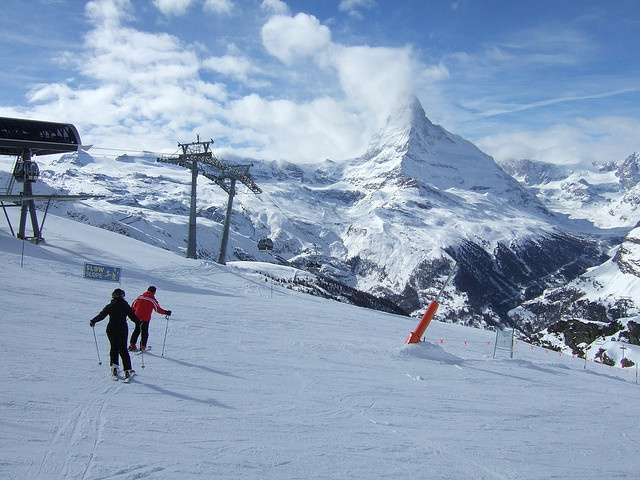Describe the objects in this image and their specific colors. I can see people in gray, black, and navy tones, people in gray, maroon, black, and darkgray tones, skis in gray, darkgray, and navy tones, and skis in gray and darkgray tones in this image. 